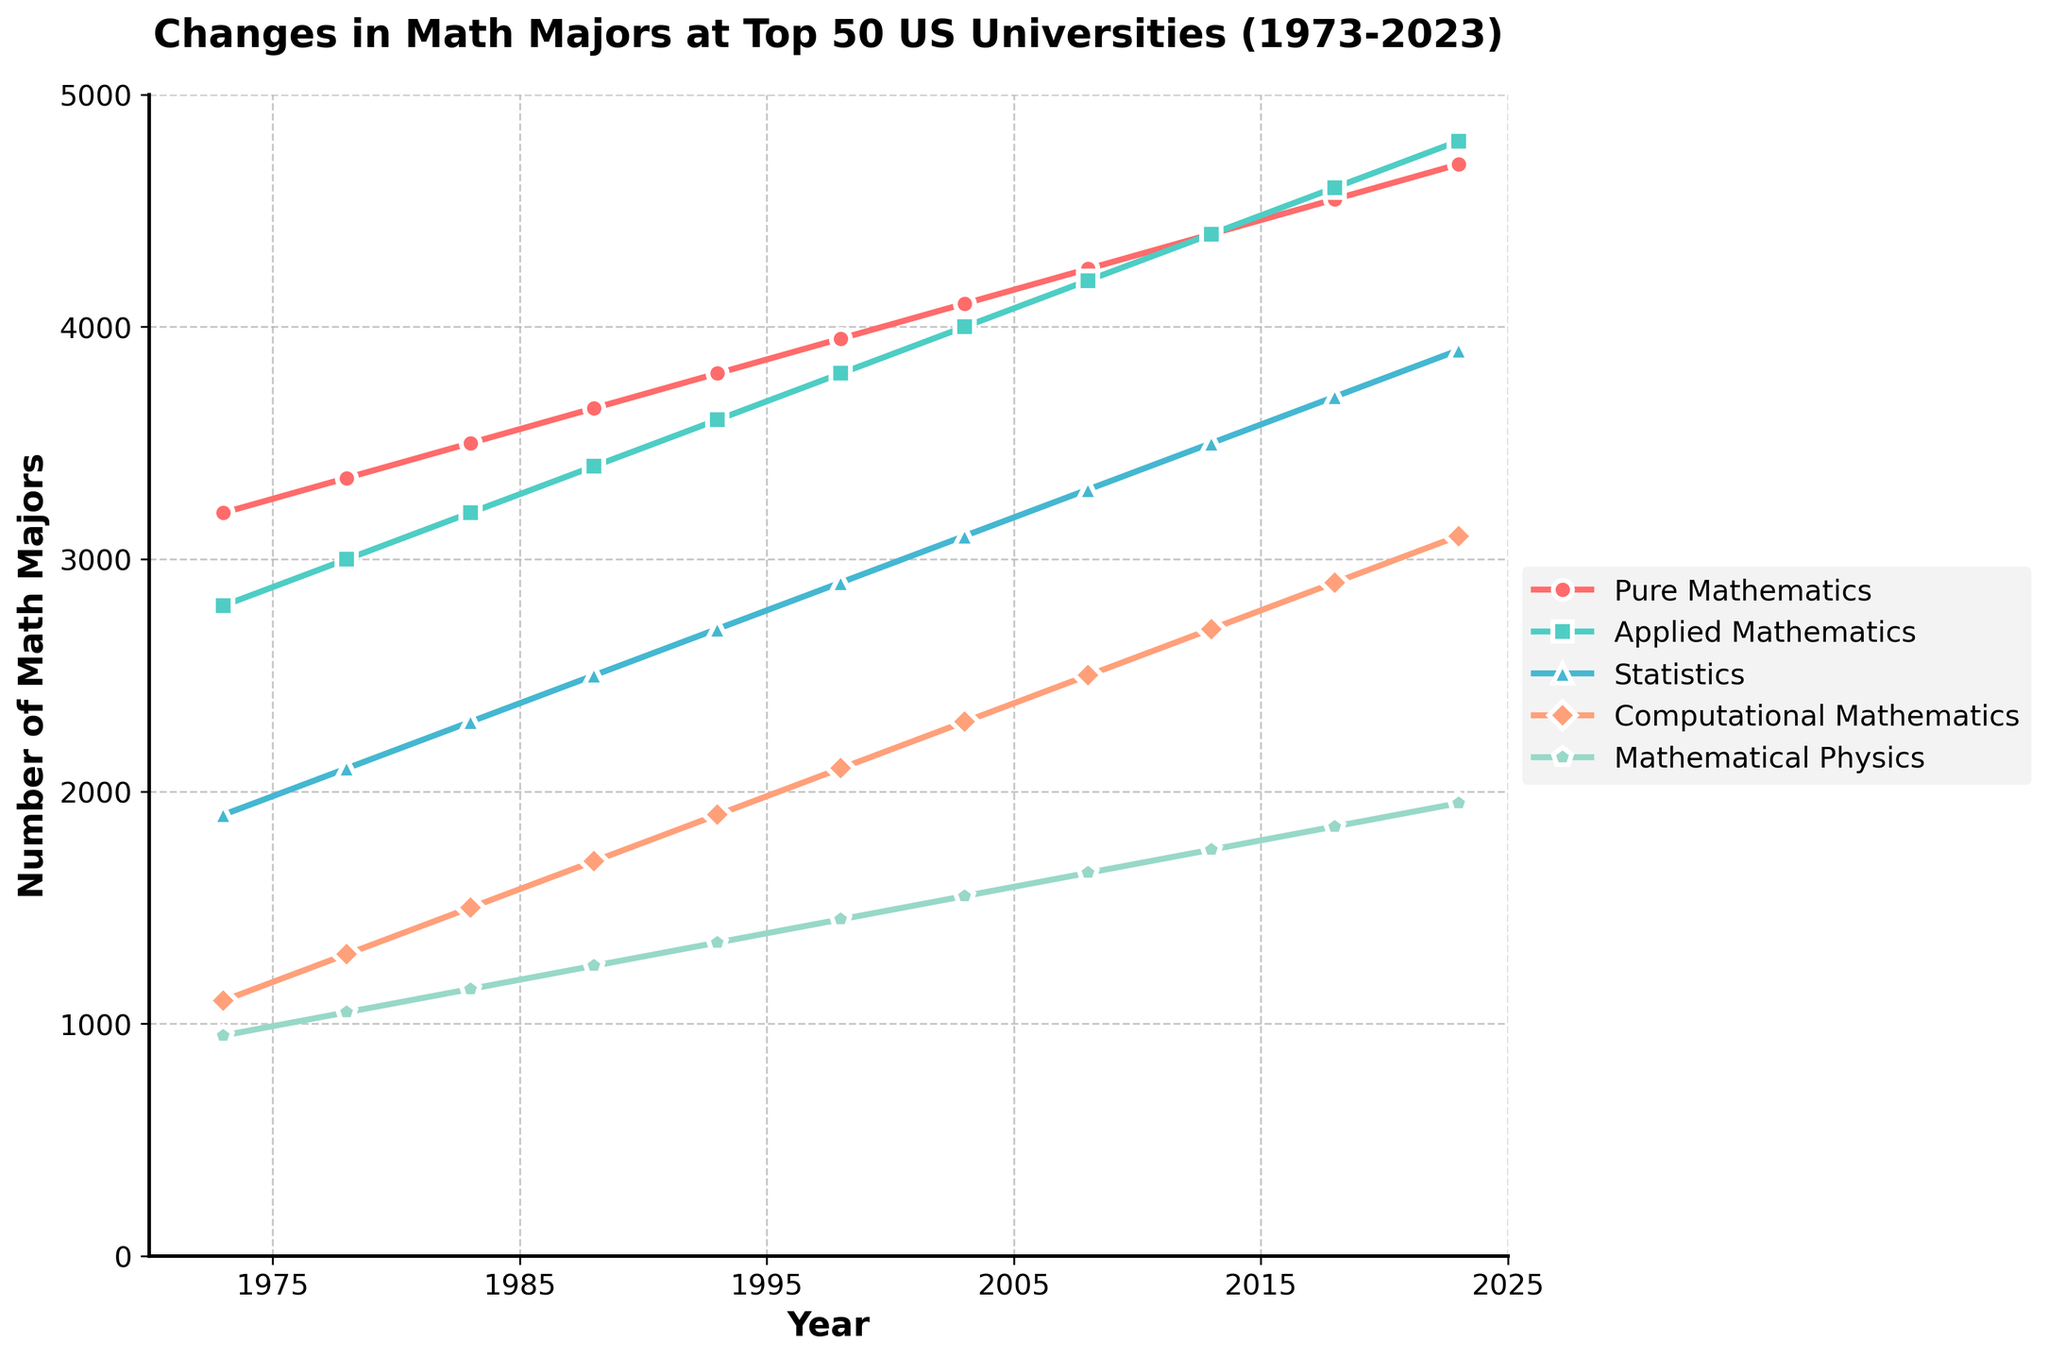What is the highest number of majors observed for any specialization in 2023? To determine the highest number of majors for any specialization in 2023, look at the point values on the rightmost side of the figure. The values are directly indicated by the plotted data points. The highest value can be found in the "Applied Mathematics" specialization.
Answer: 4800 How many more majors were there in Applied Mathematics compared to Pure Mathematics in 1988? In 1988, the number of majors in Applied Mathematics was 3400 and in Pure Mathematics was 3650. To find the difference, subtract the number of Pure Mathematics majors from the Applied Mathematics majors: 3400 - 3650 = -250. This signifies that there were 250 fewer majors in Applied Mathematics than in Pure Mathematics.
Answer: -250 What is the average number of majors in Computational Mathematics over the period 1973 to 2023? To find the average, sum the values for Computational Mathematics from 1973 to 2023 and then divide by the number of years (11):
(1100 + 1300 + 1500 + 1700 + 1900 + 2100 + 2300 + 2500 + 2700 + 2900 + 3100) / 11 
= 24000 / 11 ≈ 2182
Answer: 2182 